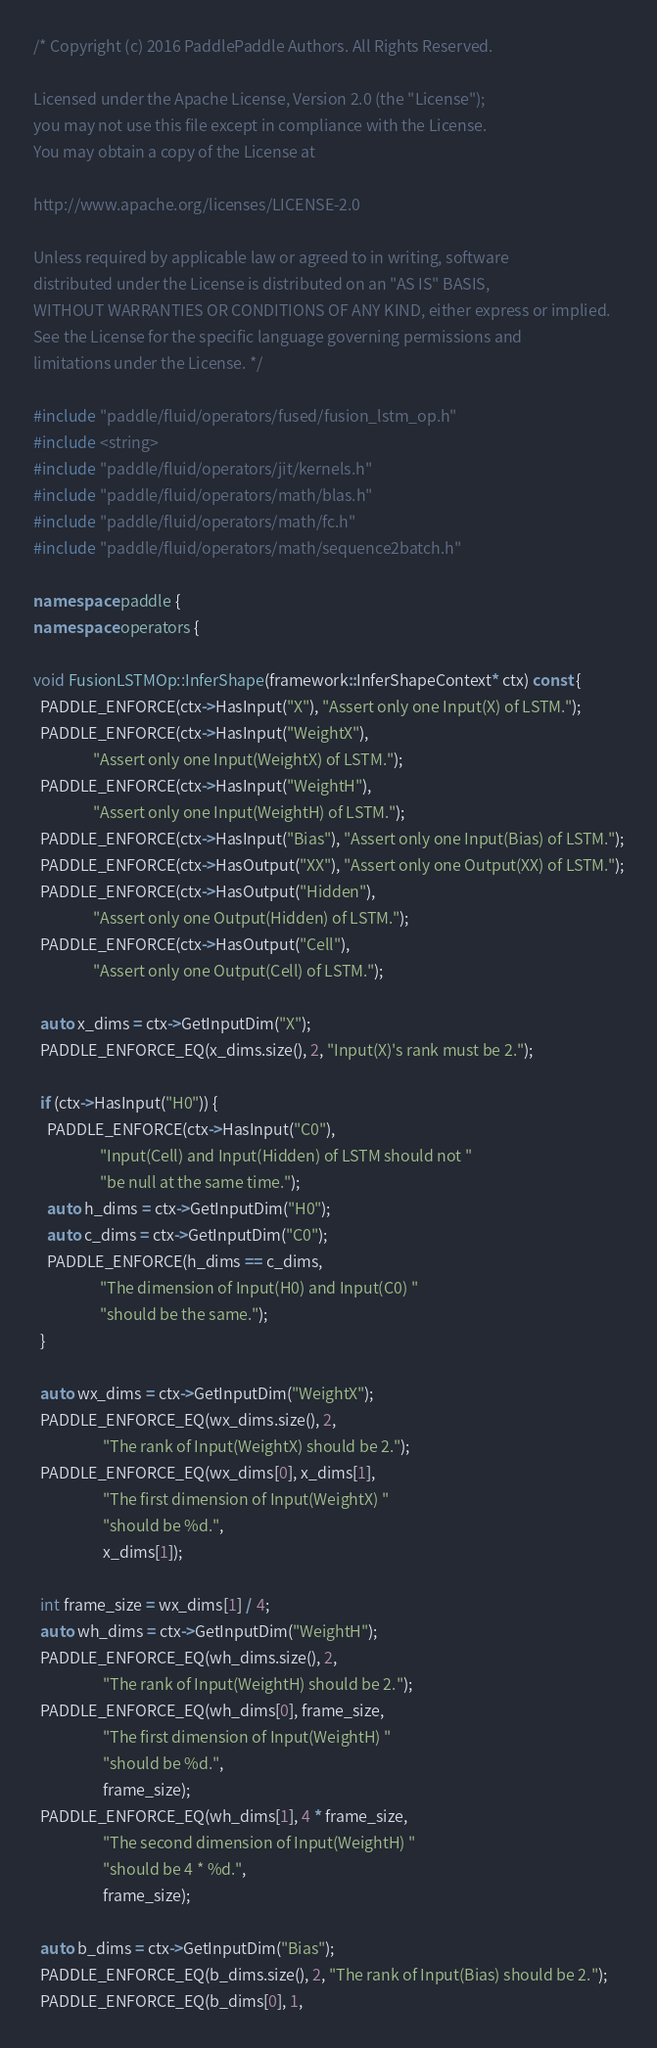Convert code to text. <code><loc_0><loc_0><loc_500><loc_500><_C++_>/* Copyright (c) 2016 PaddlePaddle Authors. All Rights Reserved.

Licensed under the Apache License, Version 2.0 (the "License");
you may not use this file except in compliance with the License.
You may obtain a copy of the License at

http://www.apache.org/licenses/LICENSE-2.0

Unless required by applicable law or agreed to in writing, software
distributed under the License is distributed on an "AS IS" BASIS,
WITHOUT WARRANTIES OR CONDITIONS OF ANY KIND, either express or implied.
See the License for the specific language governing permissions and
limitations under the License. */

#include "paddle/fluid/operators/fused/fusion_lstm_op.h"
#include <string>
#include "paddle/fluid/operators/jit/kernels.h"
#include "paddle/fluid/operators/math/blas.h"
#include "paddle/fluid/operators/math/fc.h"
#include "paddle/fluid/operators/math/sequence2batch.h"

namespace paddle {
namespace operators {

void FusionLSTMOp::InferShape(framework::InferShapeContext* ctx) const {
  PADDLE_ENFORCE(ctx->HasInput("X"), "Assert only one Input(X) of LSTM.");
  PADDLE_ENFORCE(ctx->HasInput("WeightX"),
                 "Assert only one Input(WeightX) of LSTM.");
  PADDLE_ENFORCE(ctx->HasInput("WeightH"),
                 "Assert only one Input(WeightH) of LSTM.");
  PADDLE_ENFORCE(ctx->HasInput("Bias"), "Assert only one Input(Bias) of LSTM.");
  PADDLE_ENFORCE(ctx->HasOutput("XX"), "Assert only one Output(XX) of LSTM.");
  PADDLE_ENFORCE(ctx->HasOutput("Hidden"),
                 "Assert only one Output(Hidden) of LSTM.");
  PADDLE_ENFORCE(ctx->HasOutput("Cell"),
                 "Assert only one Output(Cell) of LSTM.");

  auto x_dims = ctx->GetInputDim("X");
  PADDLE_ENFORCE_EQ(x_dims.size(), 2, "Input(X)'s rank must be 2.");

  if (ctx->HasInput("H0")) {
    PADDLE_ENFORCE(ctx->HasInput("C0"),
                   "Input(Cell) and Input(Hidden) of LSTM should not "
                   "be null at the same time.");
    auto h_dims = ctx->GetInputDim("H0");
    auto c_dims = ctx->GetInputDim("C0");
    PADDLE_ENFORCE(h_dims == c_dims,
                   "The dimension of Input(H0) and Input(C0) "
                   "should be the same.");
  }

  auto wx_dims = ctx->GetInputDim("WeightX");
  PADDLE_ENFORCE_EQ(wx_dims.size(), 2,
                    "The rank of Input(WeightX) should be 2.");
  PADDLE_ENFORCE_EQ(wx_dims[0], x_dims[1],
                    "The first dimension of Input(WeightX) "
                    "should be %d.",
                    x_dims[1]);

  int frame_size = wx_dims[1] / 4;
  auto wh_dims = ctx->GetInputDim("WeightH");
  PADDLE_ENFORCE_EQ(wh_dims.size(), 2,
                    "The rank of Input(WeightH) should be 2.");
  PADDLE_ENFORCE_EQ(wh_dims[0], frame_size,
                    "The first dimension of Input(WeightH) "
                    "should be %d.",
                    frame_size);
  PADDLE_ENFORCE_EQ(wh_dims[1], 4 * frame_size,
                    "The second dimension of Input(WeightH) "
                    "should be 4 * %d.",
                    frame_size);

  auto b_dims = ctx->GetInputDim("Bias");
  PADDLE_ENFORCE_EQ(b_dims.size(), 2, "The rank of Input(Bias) should be 2.");
  PADDLE_ENFORCE_EQ(b_dims[0], 1,</code> 